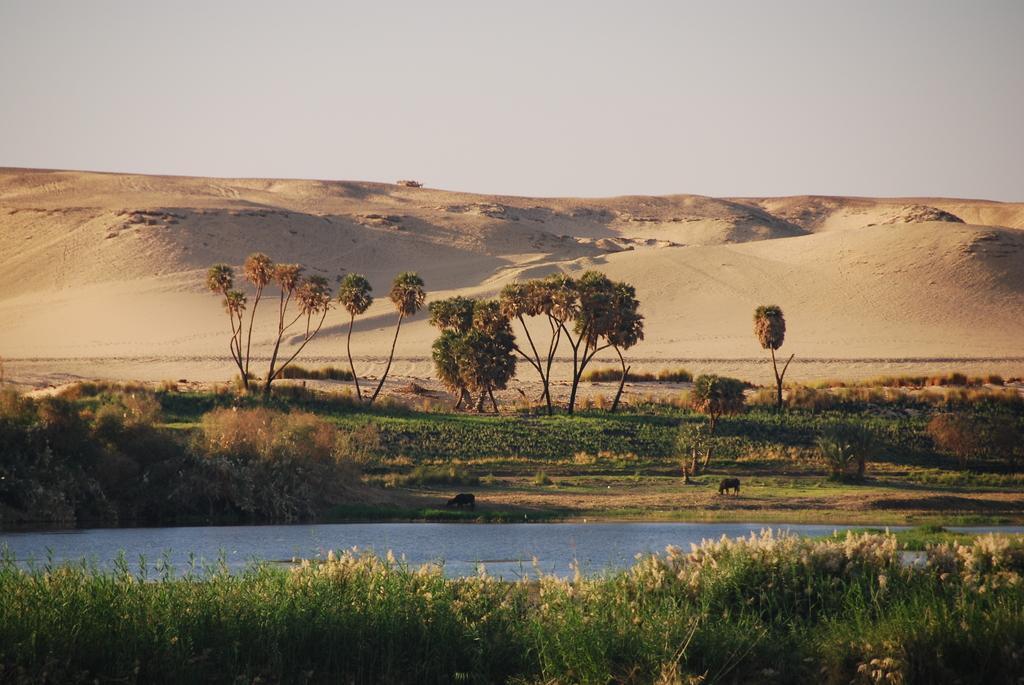Describe this image in one or two sentences. In this image, we can see a canal. There are plants at the bottom of the image. There are hills and some trees in the middle of the image. There is a sky at the top of the image. 